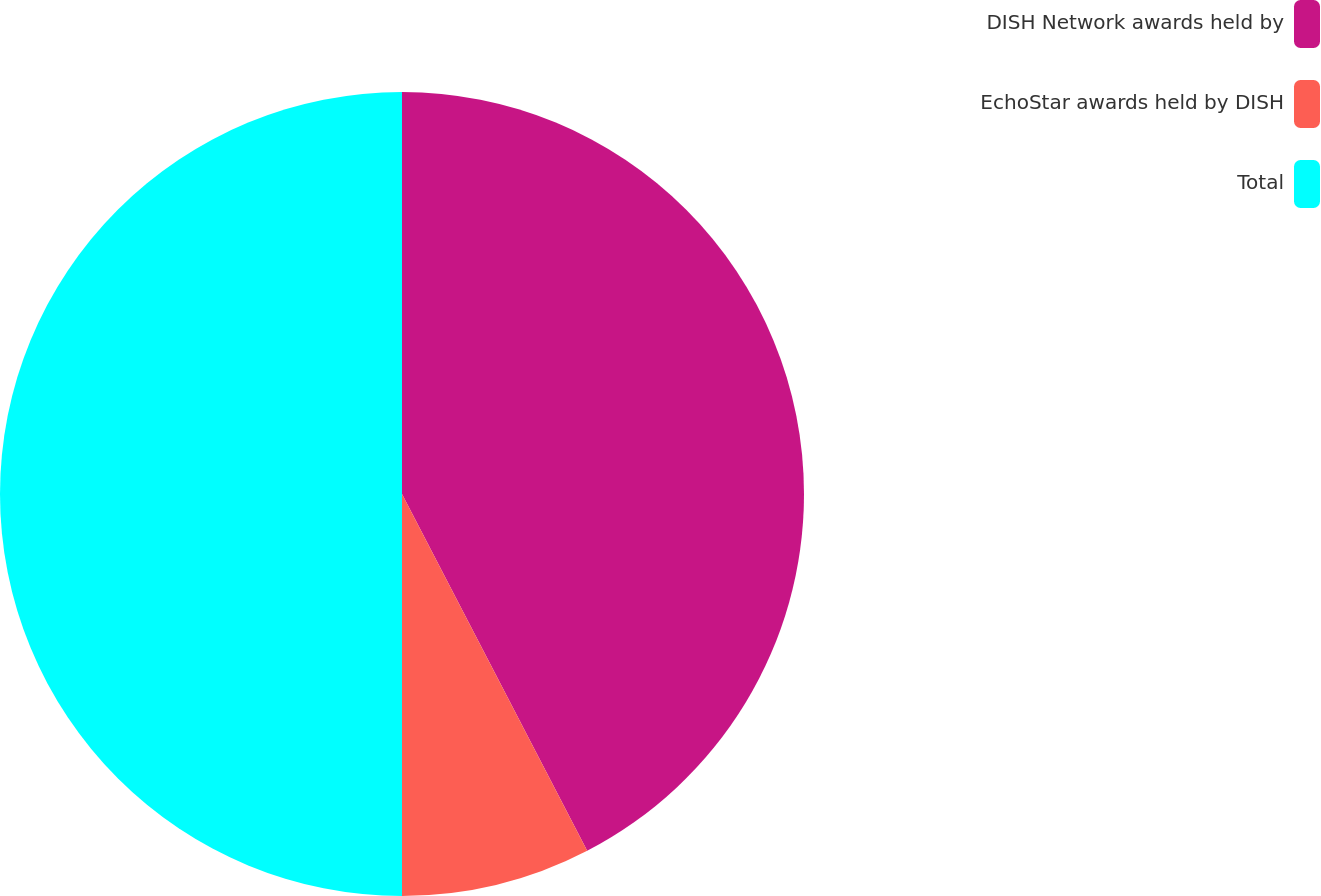Convert chart. <chart><loc_0><loc_0><loc_500><loc_500><pie_chart><fcel>DISH Network awards held by<fcel>EchoStar awards held by DISH<fcel>Total<nl><fcel>42.38%<fcel>7.62%<fcel>50.0%<nl></chart> 